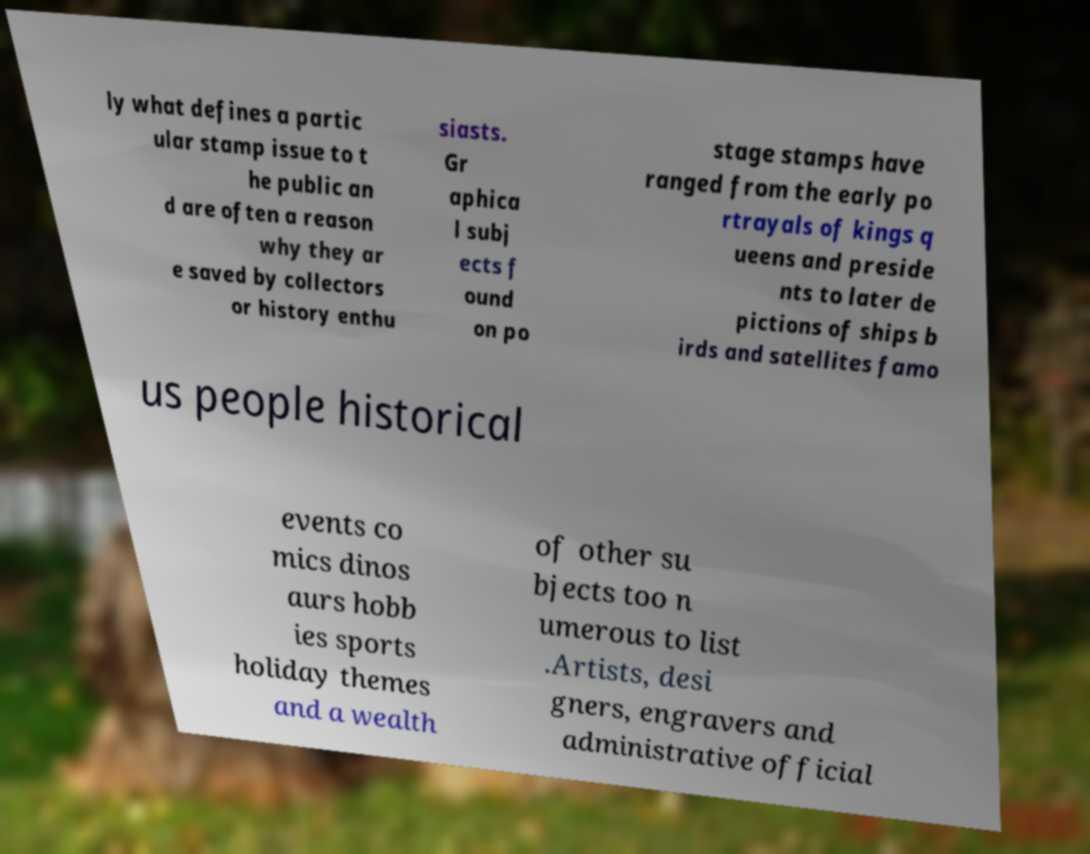Could you assist in decoding the text presented in this image and type it out clearly? ly what defines a partic ular stamp issue to t he public an d are often a reason why they ar e saved by collectors or history enthu siasts. Gr aphica l subj ects f ound on po stage stamps have ranged from the early po rtrayals of kings q ueens and preside nts to later de pictions of ships b irds and satellites famo us people historical events co mics dinos aurs hobb ies sports holiday themes and a wealth of other su bjects too n umerous to list .Artists, desi gners, engravers and administrative official 